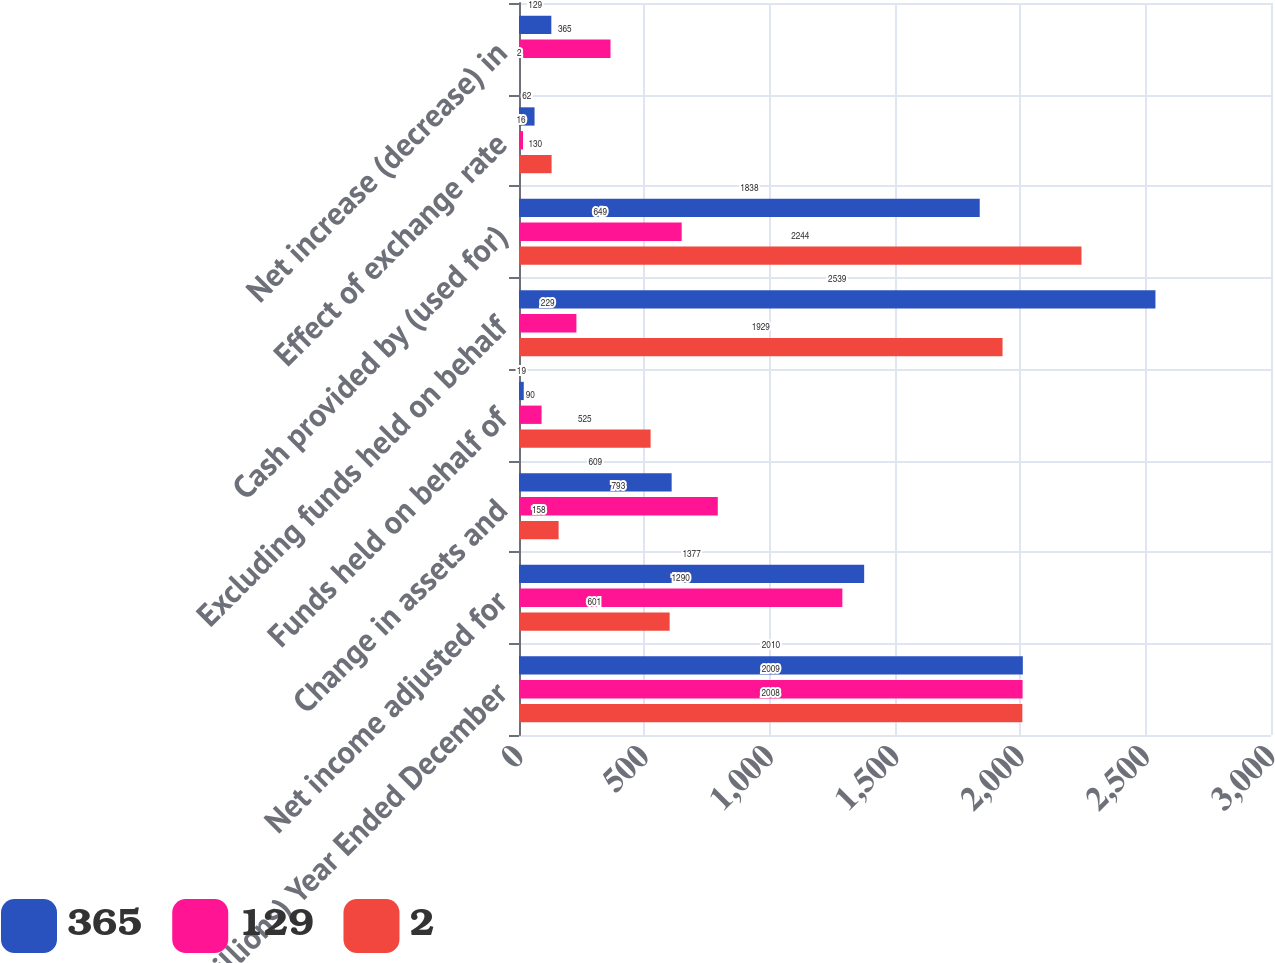<chart> <loc_0><loc_0><loc_500><loc_500><stacked_bar_chart><ecel><fcel>(millions) Year Ended December<fcel>Net income adjusted for<fcel>Change in assets and<fcel>Funds held on behalf of<fcel>Excluding funds held on behalf<fcel>Cash provided by (used for)<fcel>Effect of exchange rate<fcel>Net increase (decrease) in<nl><fcel>365<fcel>2010<fcel>1377<fcel>609<fcel>19<fcel>2539<fcel>1838<fcel>62<fcel>129<nl><fcel>129<fcel>2009<fcel>1290<fcel>793<fcel>90<fcel>229<fcel>649<fcel>16<fcel>365<nl><fcel>2<fcel>2008<fcel>601<fcel>158<fcel>525<fcel>1929<fcel>2244<fcel>130<fcel>2<nl></chart> 